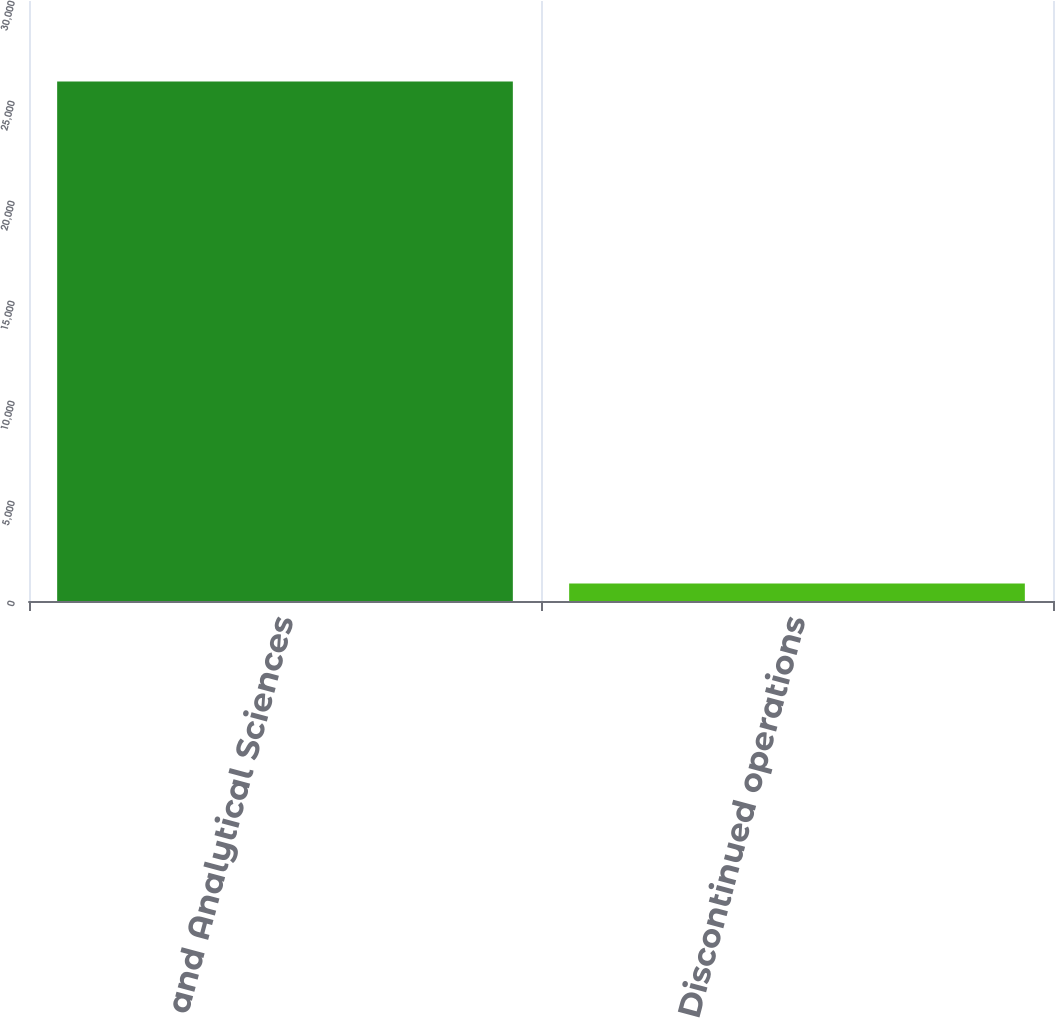Convert chart to OTSL. <chart><loc_0><loc_0><loc_500><loc_500><bar_chart><fcel>Life and Analytical Sciences<fcel>Discontinued operations<nl><fcel>25973<fcel>881<nl></chart> 